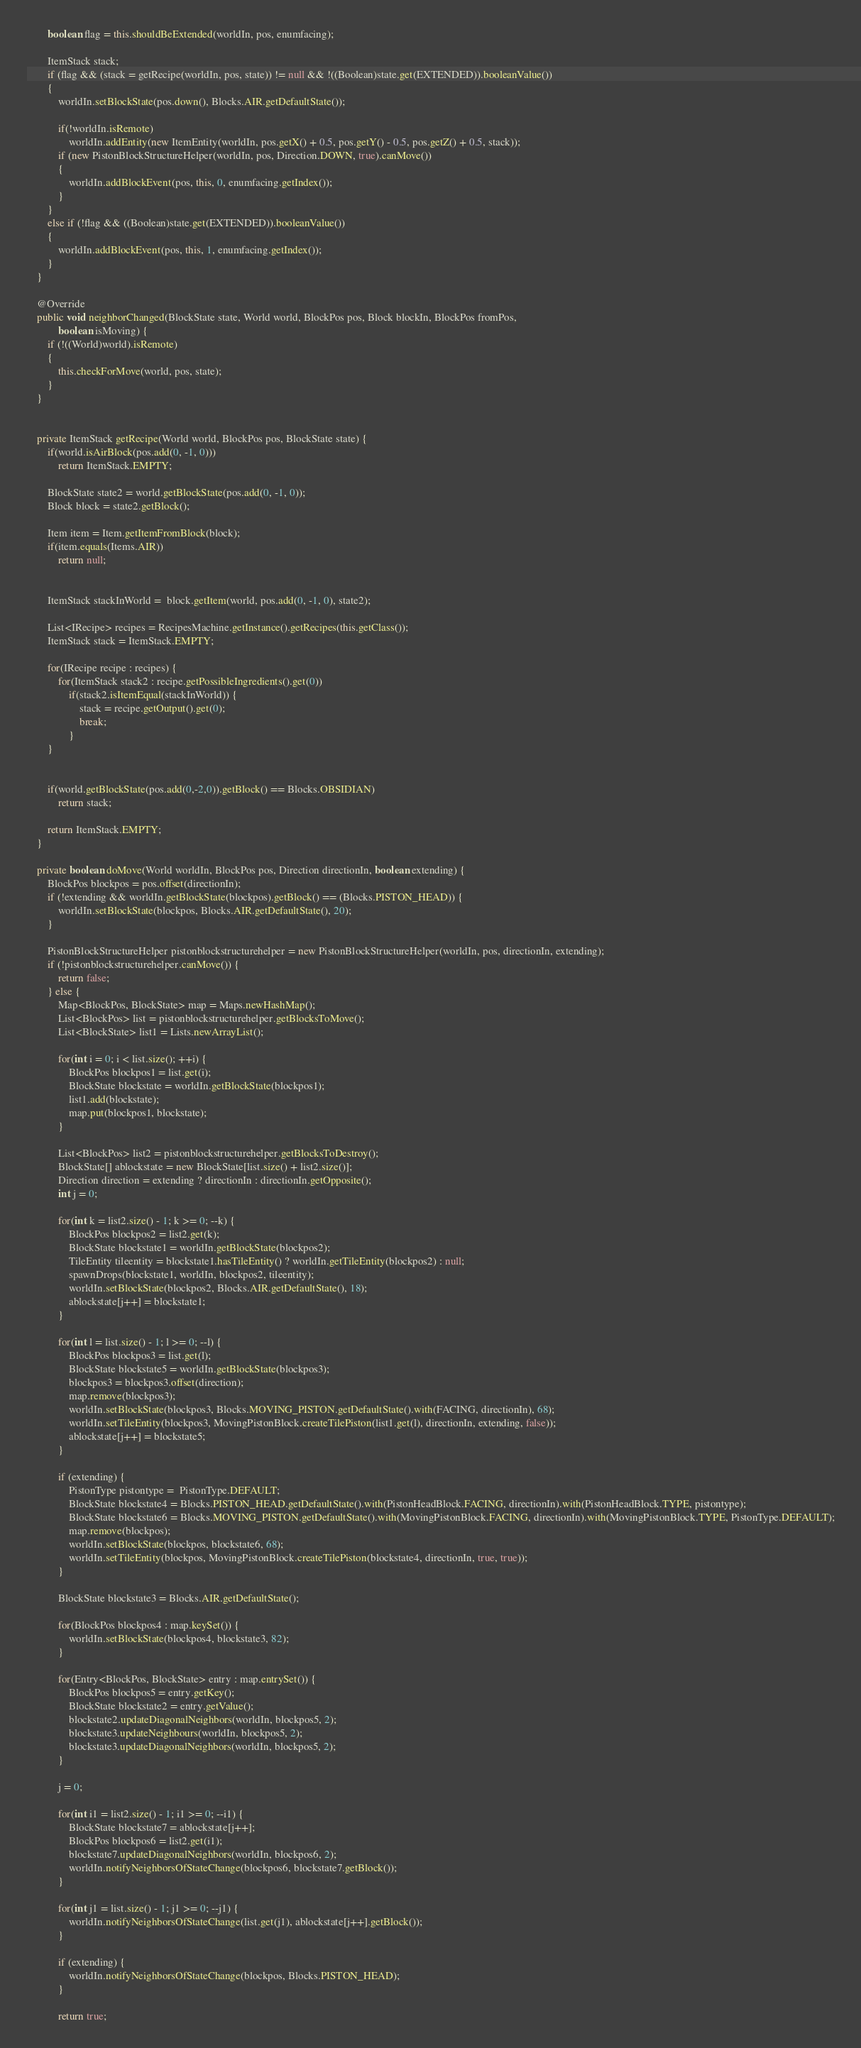Convert code to text. <code><loc_0><loc_0><loc_500><loc_500><_Java_>		boolean flag = this.shouldBeExtended(worldIn, pos, enumfacing);

		ItemStack stack;
		if (flag && (stack = getRecipe(worldIn, pos, state)) != null && !((Boolean)state.get(EXTENDED)).booleanValue())
		{
			worldIn.setBlockState(pos.down(), Blocks.AIR.getDefaultState());

			if(!worldIn.isRemote)
				worldIn.addEntity(new ItemEntity(worldIn, pos.getX() + 0.5, pos.getY() - 0.5, pos.getZ() + 0.5, stack));
			if (new PistonBlockStructureHelper(worldIn, pos, Direction.DOWN, true).canMove())
			{
				worldIn.addBlockEvent(pos, this, 0, enumfacing.getIndex());
			}
		}
		else if (!flag && ((Boolean)state.get(EXTENDED)).booleanValue())
		{
			worldIn.addBlockEvent(pos, this, 1, enumfacing.getIndex());
		}
	}

	@Override
	public void neighborChanged(BlockState state, World world, BlockPos pos, Block blockIn, BlockPos fromPos,
			boolean isMoving) {
		if (!((World)world).isRemote)
		{
			this.checkForMove(world, pos, state);
		}
	}


	private ItemStack getRecipe(World world, BlockPos pos, BlockState state) {
		if(world.isAirBlock(pos.add(0, -1, 0)))
			return ItemStack.EMPTY;

		BlockState state2 = world.getBlockState(pos.add(0, -1, 0));
		Block block = state2.getBlock();

		Item item = Item.getItemFromBlock(block);
		if(item.equals(Items.AIR))
			return null;


		ItemStack stackInWorld =  block.getItem(world, pos.add(0, -1, 0), state2);

		List<IRecipe> recipes = RecipesMachine.getInstance().getRecipes(this.getClass());
		ItemStack stack = ItemStack.EMPTY;

		for(IRecipe recipe : recipes) {
			for(ItemStack stack2 : recipe.getPossibleIngredients().get(0))
				if(stack2.isItemEqual(stackInWorld)) {
					stack = recipe.getOutput().get(0);
					break;
				}
		}


		if(world.getBlockState(pos.add(0,-2,0)).getBlock() == Blocks.OBSIDIAN)
			return stack;

		return ItemStack.EMPTY;
	}

	private boolean doMove(World worldIn, BlockPos pos, Direction directionIn, boolean extending) {
		BlockPos blockpos = pos.offset(directionIn);
		if (!extending && worldIn.getBlockState(blockpos).getBlock() == (Blocks.PISTON_HEAD)) {
			worldIn.setBlockState(blockpos, Blocks.AIR.getDefaultState(), 20);
		}

		PistonBlockStructureHelper pistonblockstructurehelper = new PistonBlockStructureHelper(worldIn, pos, directionIn, extending);
		if (!pistonblockstructurehelper.canMove()) {
			return false;
		} else {
			Map<BlockPos, BlockState> map = Maps.newHashMap();
			List<BlockPos> list = pistonblockstructurehelper.getBlocksToMove();
			List<BlockState> list1 = Lists.newArrayList();

			for(int i = 0; i < list.size(); ++i) {
				BlockPos blockpos1 = list.get(i);
				BlockState blockstate = worldIn.getBlockState(blockpos1);
				list1.add(blockstate);
				map.put(blockpos1, blockstate);
			}

			List<BlockPos> list2 = pistonblockstructurehelper.getBlocksToDestroy();
			BlockState[] ablockstate = new BlockState[list.size() + list2.size()];
			Direction direction = extending ? directionIn : directionIn.getOpposite();
			int j = 0;

			for(int k = list2.size() - 1; k >= 0; --k) {
				BlockPos blockpos2 = list2.get(k);
				BlockState blockstate1 = worldIn.getBlockState(blockpos2);
				TileEntity tileentity = blockstate1.hasTileEntity() ? worldIn.getTileEntity(blockpos2) : null;
				spawnDrops(blockstate1, worldIn, blockpos2, tileentity);
				worldIn.setBlockState(blockpos2, Blocks.AIR.getDefaultState(), 18);
				ablockstate[j++] = blockstate1;
			}

			for(int l = list.size() - 1; l >= 0; --l) {
				BlockPos blockpos3 = list.get(l);
				BlockState blockstate5 = worldIn.getBlockState(blockpos3);
				blockpos3 = blockpos3.offset(direction);
				map.remove(blockpos3);
				worldIn.setBlockState(blockpos3, Blocks.MOVING_PISTON.getDefaultState().with(FACING, directionIn), 68);
				worldIn.setTileEntity(blockpos3, MovingPistonBlock.createTilePiston(list1.get(l), directionIn, extending, false));
				ablockstate[j++] = blockstate5;
			}

			if (extending) {
				PistonType pistontype =  PistonType.DEFAULT;
				BlockState blockstate4 = Blocks.PISTON_HEAD.getDefaultState().with(PistonHeadBlock.FACING, directionIn).with(PistonHeadBlock.TYPE, pistontype);
				BlockState blockstate6 = Blocks.MOVING_PISTON.getDefaultState().with(MovingPistonBlock.FACING, directionIn).with(MovingPistonBlock.TYPE, PistonType.DEFAULT);
				map.remove(blockpos);
				worldIn.setBlockState(blockpos, blockstate6, 68);
				worldIn.setTileEntity(blockpos, MovingPistonBlock.createTilePiston(blockstate4, directionIn, true, true));
			}

			BlockState blockstate3 = Blocks.AIR.getDefaultState();

			for(BlockPos blockpos4 : map.keySet()) {
				worldIn.setBlockState(blockpos4, blockstate3, 82);
			}

			for(Entry<BlockPos, BlockState> entry : map.entrySet()) {
				BlockPos blockpos5 = entry.getKey();
				BlockState blockstate2 = entry.getValue();
				blockstate2.updateDiagonalNeighbors(worldIn, blockpos5, 2);
				blockstate3.updateNeighbours(worldIn, blockpos5, 2);
				blockstate3.updateDiagonalNeighbors(worldIn, blockpos5, 2);
			}

			j = 0;

			for(int i1 = list2.size() - 1; i1 >= 0; --i1) {
				BlockState blockstate7 = ablockstate[j++];
				BlockPos blockpos6 = list2.get(i1);
				blockstate7.updateDiagonalNeighbors(worldIn, blockpos6, 2);
				worldIn.notifyNeighborsOfStateChange(blockpos6, blockstate7.getBlock());
			}

			for(int j1 = list.size() - 1; j1 >= 0; --j1) {
				worldIn.notifyNeighborsOfStateChange(list.get(j1), ablockstate[j++].getBlock());
			}

			if (extending) {
				worldIn.notifyNeighborsOfStateChange(blockpos, Blocks.PISTON_HEAD);
			}

			return true;</code> 